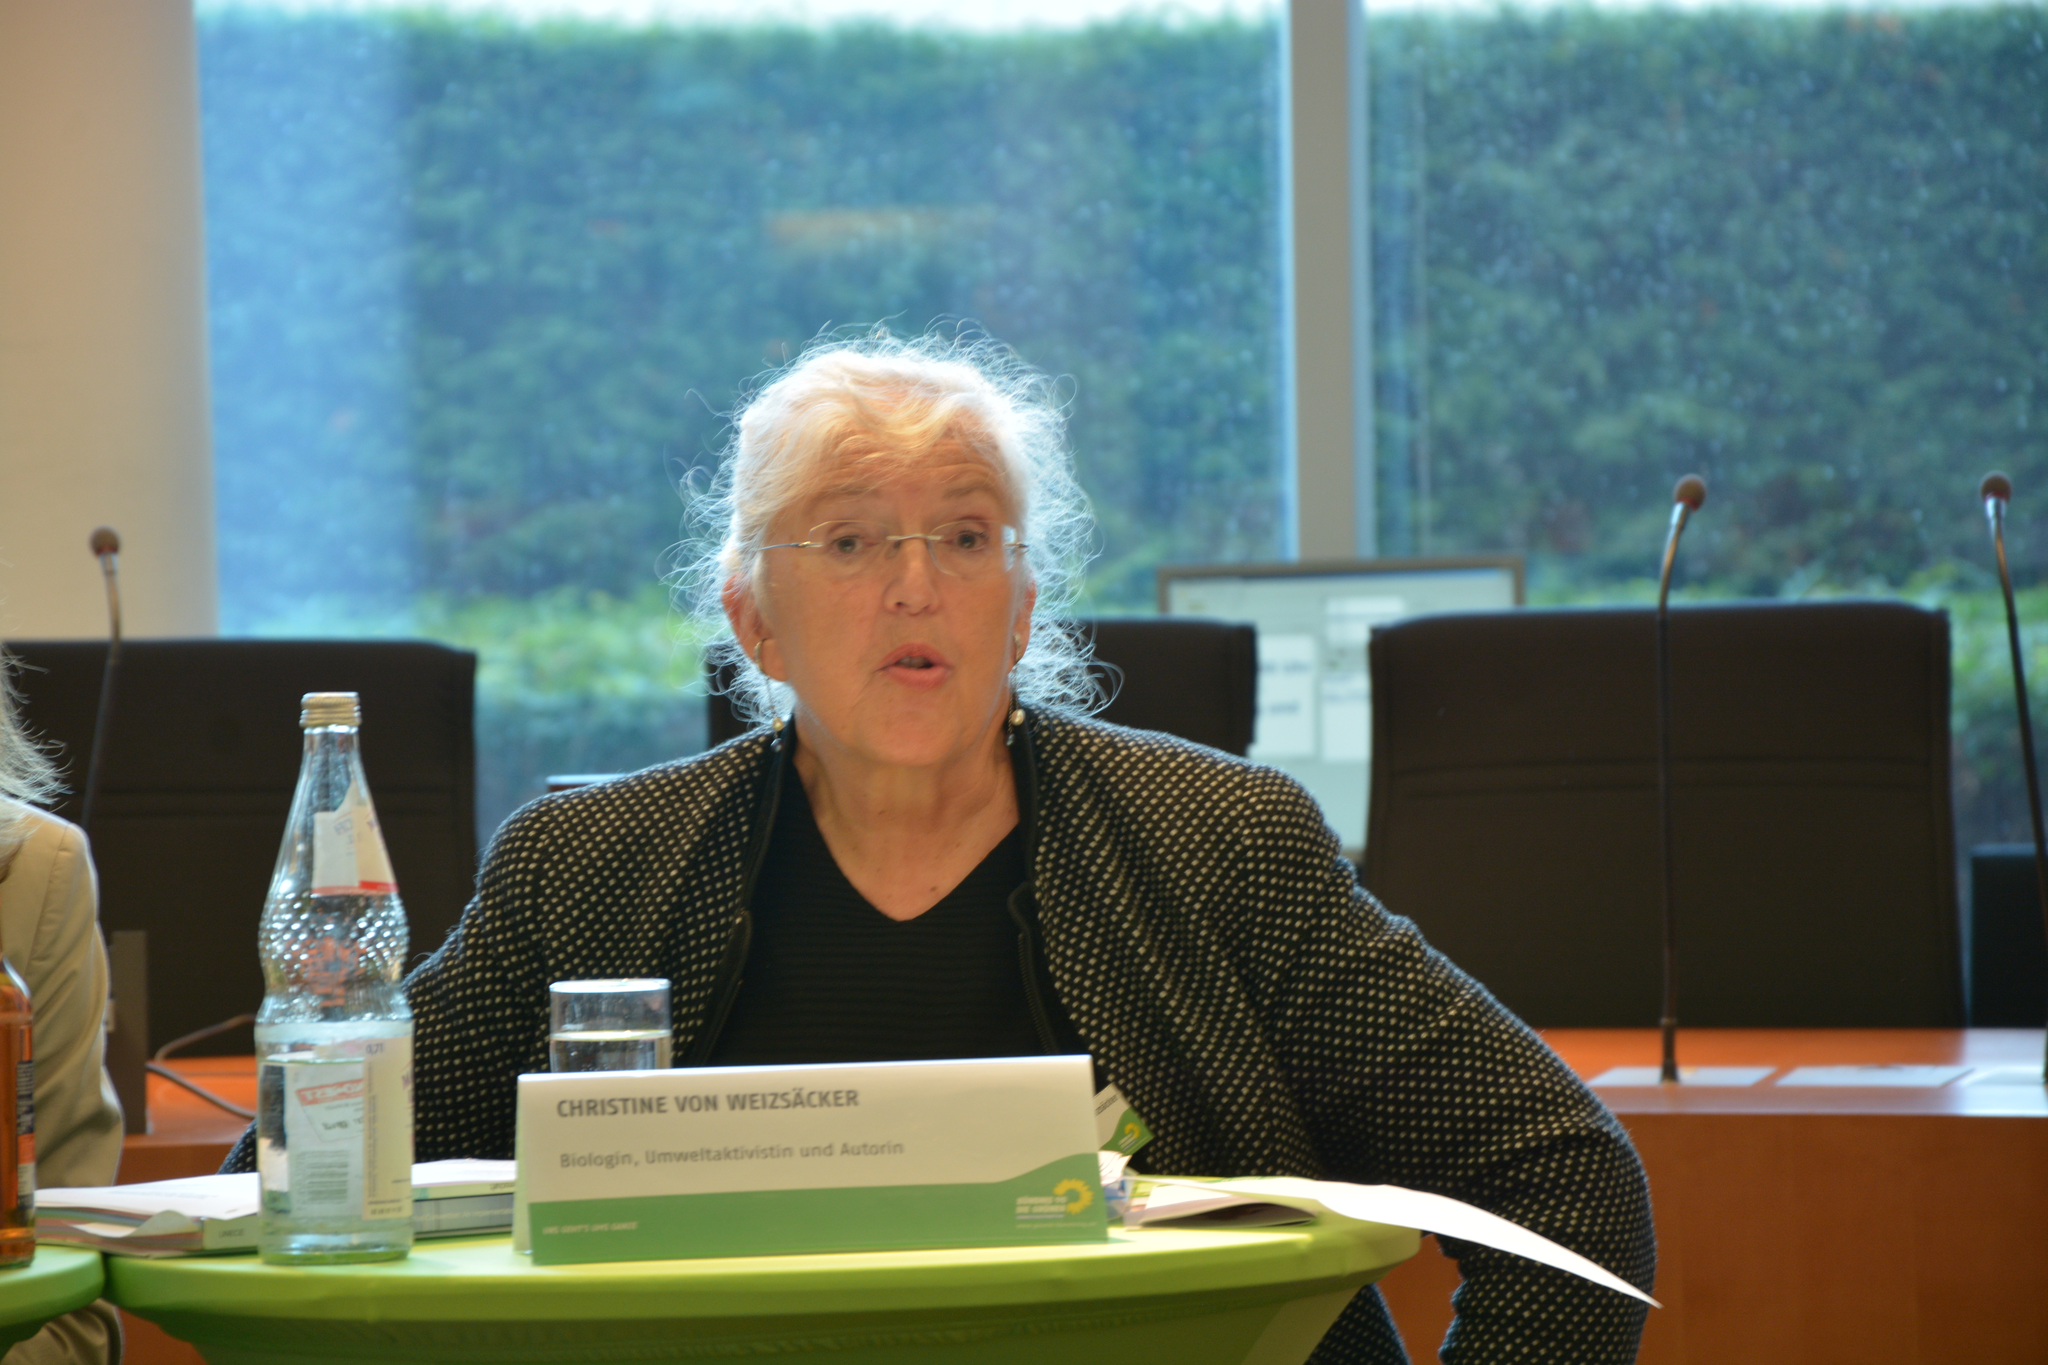What is the name of the person shown?
Provide a short and direct response. Christine von weizsacker. 